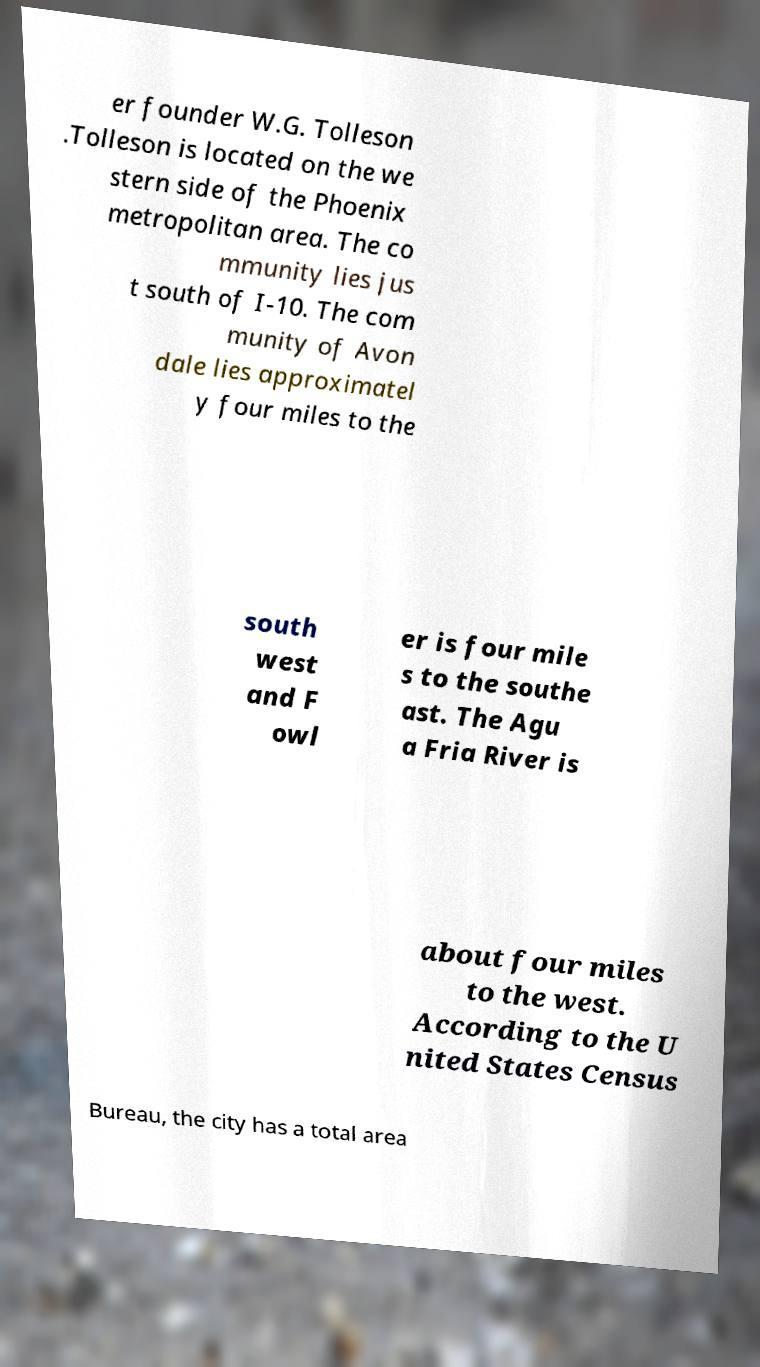I need the written content from this picture converted into text. Can you do that? er founder W.G. Tolleson .Tolleson is located on the we stern side of the Phoenix metropolitan area. The co mmunity lies jus t south of I-10. The com munity of Avon dale lies approximatel y four miles to the south west and F owl er is four mile s to the southe ast. The Agu a Fria River is about four miles to the west. According to the U nited States Census Bureau, the city has a total area 